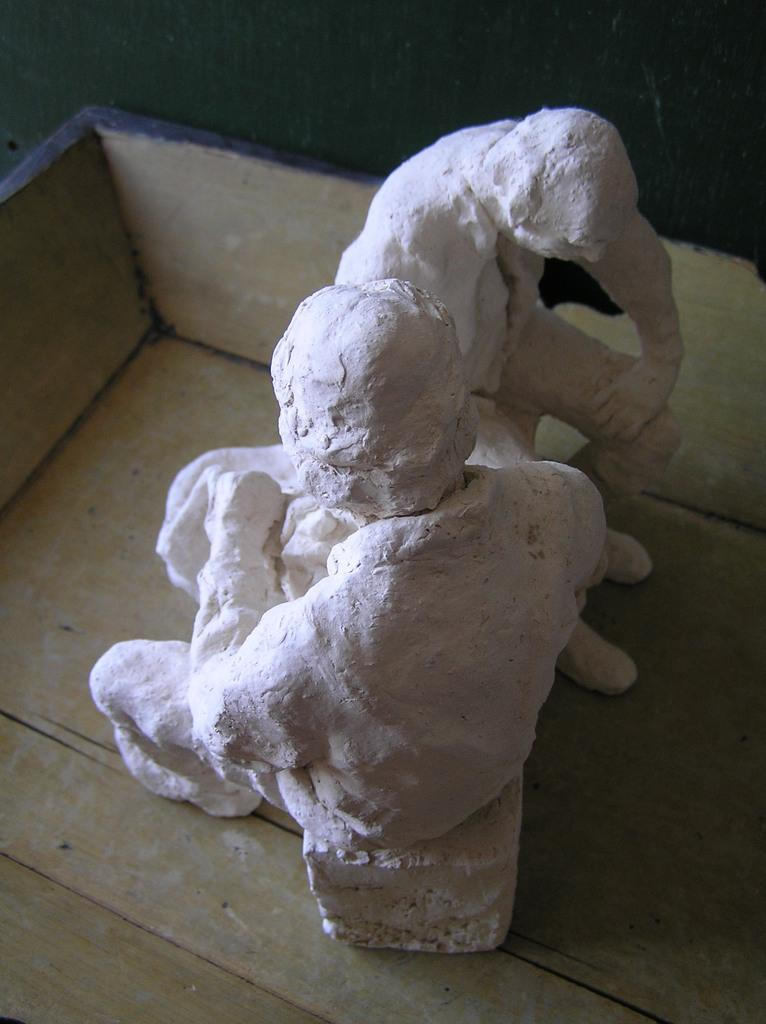What is the setting of the image? The image was likely taken indoors. What can be seen in the image besides the indoor setting? There are two sculptures of persons in the image. What are the sculptures doing? The sculptures appear to be sitting on objects. How are the sculptures displayed in the image? The sculptures are placed in a wooden box. What type of curtain can be seen hanging in the background of the image? There is no curtain visible in the image; it only shows two sculptures of persons sitting on objects and placed in a wooden box. 